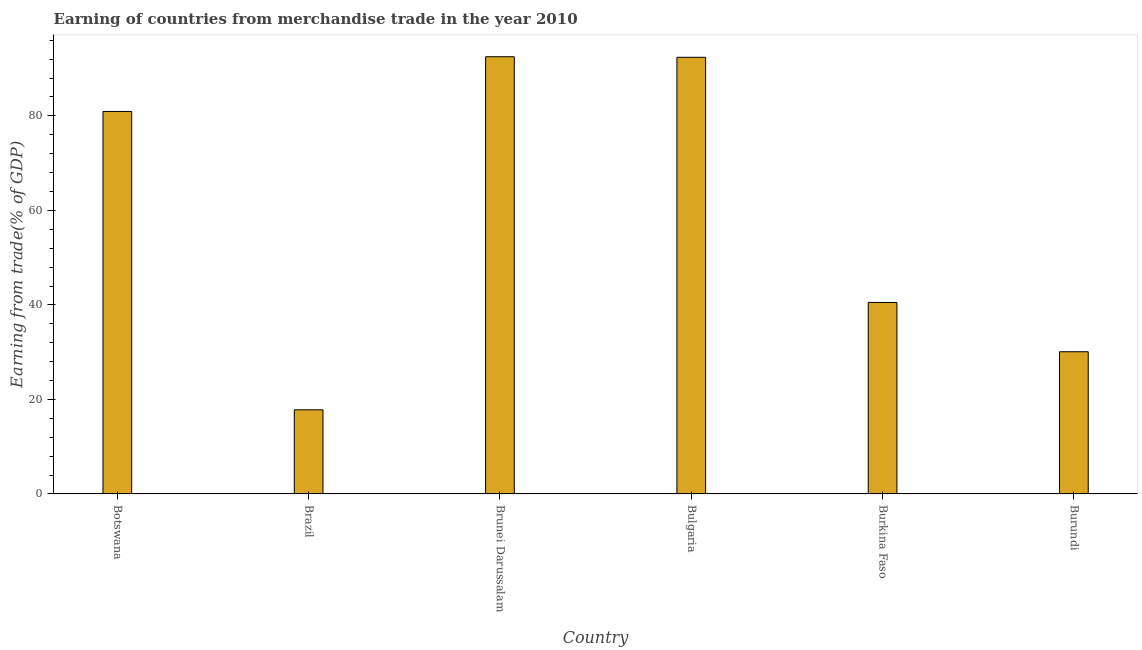Does the graph contain any zero values?
Offer a very short reply. No. What is the title of the graph?
Your response must be concise. Earning of countries from merchandise trade in the year 2010. What is the label or title of the Y-axis?
Provide a short and direct response. Earning from trade(% of GDP). What is the earning from merchandise trade in Brunei Darussalam?
Offer a very short reply. 92.52. Across all countries, what is the maximum earning from merchandise trade?
Give a very brief answer. 92.52. Across all countries, what is the minimum earning from merchandise trade?
Give a very brief answer. 17.81. In which country was the earning from merchandise trade maximum?
Your answer should be compact. Brunei Darussalam. What is the sum of the earning from merchandise trade?
Your answer should be very brief. 354.29. What is the difference between the earning from merchandise trade in Brazil and Burkina Faso?
Provide a succinct answer. -22.72. What is the average earning from merchandise trade per country?
Keep it short and to the point. 59.05. What is the median earning from merchandise trade?
Your response must be concise. 60.74. In how many countries, is the earning from merchandise trade greater than 12 %?
Offer a terse response. 6. What is the ratio of the earning from merchandise trade in Botswana to that in Burundi?
Your response must be concise. 2.69. Is the difference between the earning from merchandise trade in Botswana and Burundi greater than the difference between any two countries?
Your answer should be compact. No. What is the difference between the highest and the second highest earning from merchandise trade?
Ensure brevity in your answer.  0.12. What is the difference between the highest and the lowest earning from merchandise trade?
Give a very brief answer. 74.71. In how many countries, is the earning from merchandise trade greater than the average earning from merchandise trade taken over all countries?
Offer a terse response. 3. What is the difference between two consecutive major ticks on the Y-axis?
Your answer should be very brief. 20. Are the values on the major ticks of Y-axis written in scientific E-notation?
Ensure brevity in your answer.  No. What is the Earning from trade(% of GDP) in Botswana?
Keep it short and to the point. 80.94. What is the Earning from trade(% of GDP) in Brazil?
Your answer should be compact. 17.81. What is the Earning from trade(% of GDP) in Brunei Darussalam?
Provide a succinct answer. 92.52. What is the Earning from trade(% of GDP) of Bulgaria?
Make the answer very short. 92.4. What is the Earning from trade(% of GDP) in Burkina Faso?
Offer a very short reply. 40.53. What is the Earning from trade(% of GDP) in Burundi?
Offer a very short reply. 30.1. What is the difference between the Earning from trade(% of GDP) in Botswana and Brazil?
Provide a succinct answer. 63.14. What is the difference between the Earning from trade(% of GDP) in Botswana and Brunei Darussalam?
Offer a terse response. -11.58. What is the difference between the Earning from trade(% of GDP) in Botswana and Bulgaria?
Ensure brevity in your answer.  -11.45. What is the difference between the Earning from trade(% of GDP) in Botswana and Burkina Faso?
Make the answer very short. 40.42. What is the difference between the Earning from trade(% of GDP) in Botswana and Burundi?
Offer a terse response. 50.85. What is the difference between the Earning from trade(% of GDP) in Brazil and Brunei Darussalam?
Your answer should be compact. -74.71. What is the difference between the Earning from trade(% of GDP) in Brazil and Bulgaria?
Provide a succinct answer. -74.59. What is the difference between the Earning from trade(% of GDP) in Brazil and Burkina Faso?
Your answer should be very brief. -22.72. What is the difference between the Earning from trade(% of GDP) in Brazil and Burundi?
Keep it short and to the point. -12.29. What is the difference between the Earning from trade(% of GDP) in Brunei Darussalam and Bulgaria?
Your response must be concise. 0.12. What is the difference between the Earning from trade(% of GDP) in Brunei Darussalam and Burkina Faso?
Your response must be concise. 51.99. What is the difference between the Earning from trade(% of GDP) in Brunei Darussalam and Burundi?
Your answer should be compact. 62.42. What is the difference between the Earning from trade(% of GDP) in Bulgaria and Burkina Faso?
Provide a succinct answer. 51.87. What is the difference between the Earning from trade(% of GDP) in Bulgaria and Burundi?
Give a very brief answer. 62.3. What is the difference between the Earning from trade(% of GDP) in Burkina Faso and Burundi?
Offer a terse response. 10.43. What is the ratio of the Earning from trade(% of GDP) in Botswana to that in Brazil?
Provide a short and direct response. 4.54. What is the ratio of the Earning from trade(% of GDP) in Botswana to that in Bulgaria?
Keep it short and to the point. 0.88. What is the ratio of the Earning from trade(% of GDP) in Botswana to that in Burkina Faso?
Offer a terse response. 2. What is the ratio of the Earning from trade(% of GDP) in Botswana to that in Burundi?
Offer a terse response. 2.69. What is the ratio of the Earning from trade(% of GDP) in Brazil to that in Brunei Darussalam?
Offer a very short reply. 0.19. What is the ratio of the Earning from trade(% of GDP) in Brazil to that in Bulgaria?
Provide a short and direct response. 0.19. What is the ratio of the Earning from trade(% of GDP) in Brazil to that in Burkina Faso?
Your response must be concise. 0.44. What is the ratio of the Earning from trade(% of GDP) in Brazil to that in Burundi?
Your answer should be very brief. 0.59. What is the ratio of the Earning from trade(% of GDP) in Brunei Darussalam to that in Bulgaria?
Offer a very short reply. 1. What is the ratio of the Earning from trade(% of GDP) in Brunei Darussalam to that in Burkina Faso?
Your answer should be compact. 2.28. What is the ratio of the Earning from trade(% of GDP) in Brunei Darussalam to that in Burundi?
Offer a terse response. 3.07. What is the ratio of the Earning from trade(% of GDP) in Bulgaria to that in Burkina Faso?
Ensure brevity in your answer.  2.28. What is the ratio of the Earning from trade(% of GDP) in Bulgaria to that in Burundi?
Your answer should be compact. 3.07. What is the ratio of the Earning from trade(% of GDP) in Burkina Faso to that in Burundi?
Offer a terse response. 1.35. 